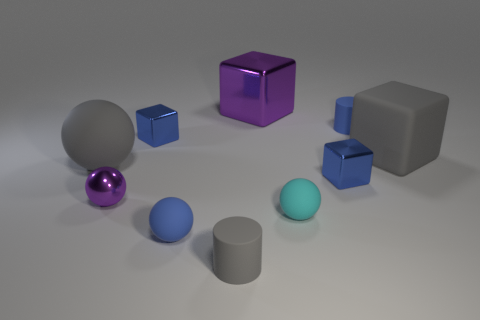Subtract all big spheres. How many spheres are left? 3 Subtract all blue cylinders. How many blue cubes are left? 2 Subtract all cubes. How many objects are left? 6 Subtract 2 cylinders. How many cylinders are left? 0 Subtract all gray spheres. Subtract all green cubes. How many spheres are left? 3 Subtract all matte cubes. Subtract all blue metallic things. How many objects are left? 7 Add 2 big blocks. How many big blocks are left? 4 Add 5 tiny shiny things. How many tiny shiny things exist? 8 Subtract all purple balls. How many balls are left? 3 Subtract 1 gray cylinders. How many objects are left? 9 